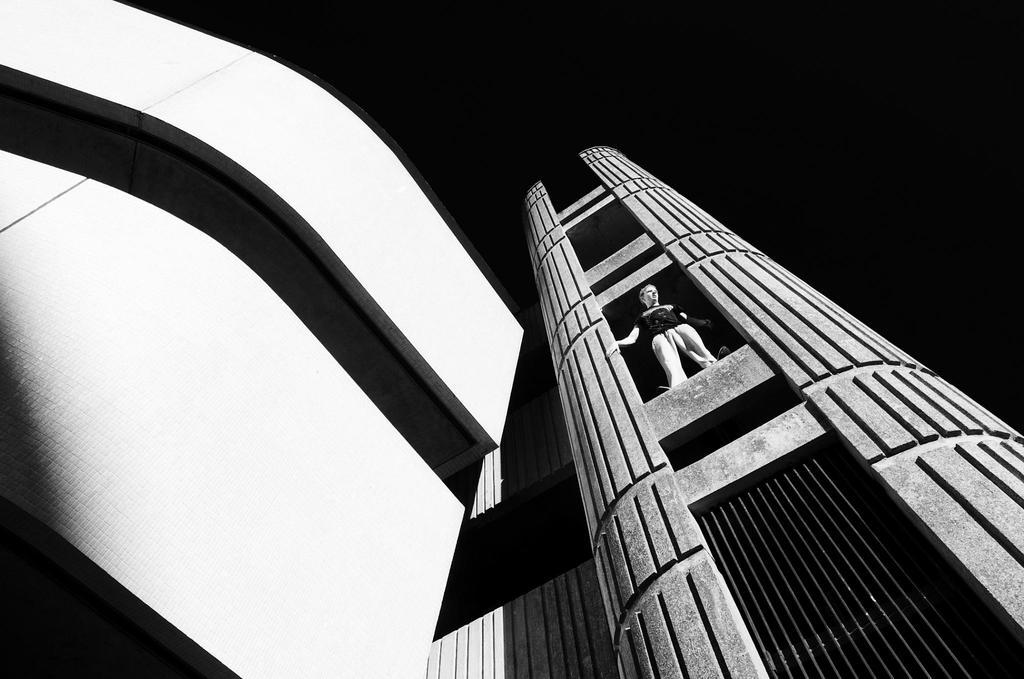What structures are visible in the image? There are buildings in the image. Can you describe the person in the image? There is a person standing in the middle of the image. What is the color of the background in the image? The background of the image is dark. What type of books can be seen in the hands of the person in the image? There are no books visible in the image; the person is not holding anything. What kind of sponge is being used to clean the buildings in the image? There is no sponge present in the image, and the buildings are not being cleaned. 